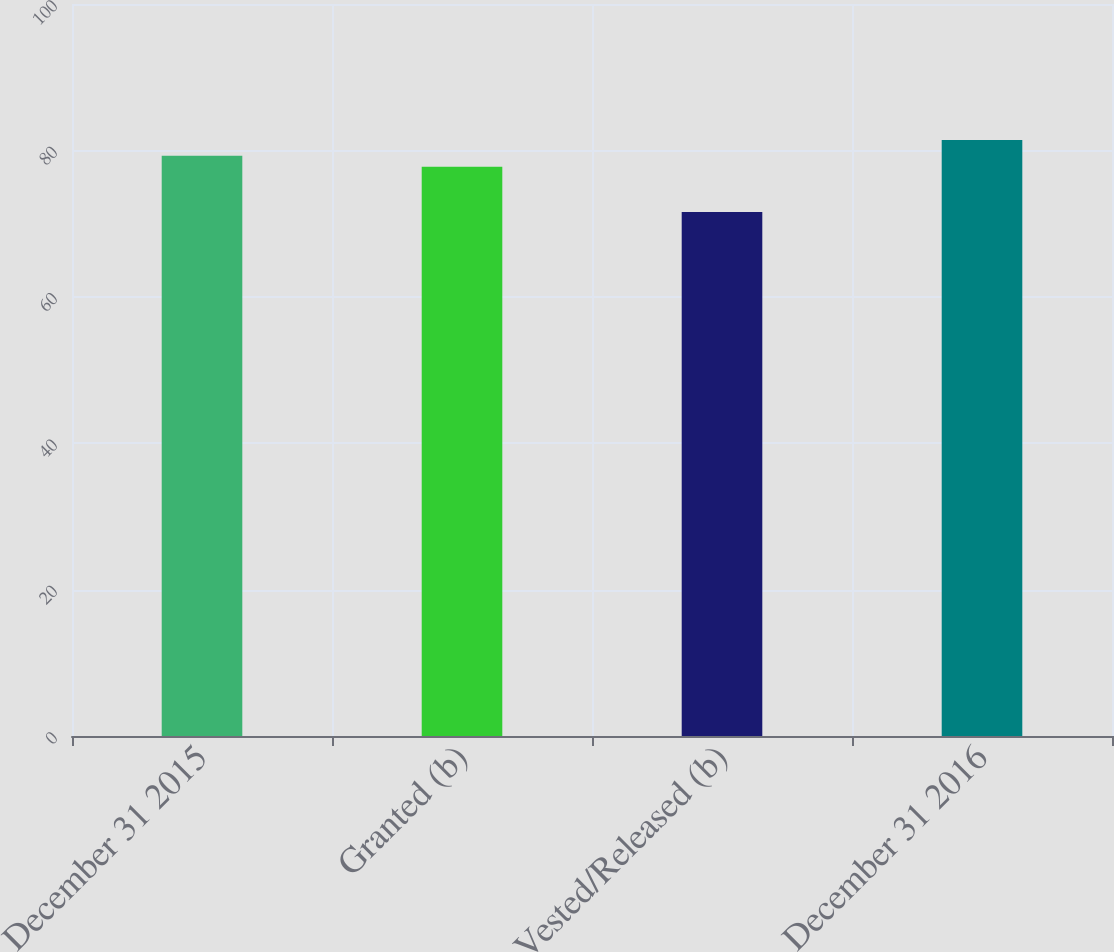Convert chart. <chart><loc_0><loc_0><loc_500><loc_500><bar_chart><fcel>December 31 2015<fcel>Granted (b)<fcel>Vested/Released (b)<fcel>December 31 2016<nl><fcel>79.27<fcel>77.77<fcel>71.59<fcel>81.42<nl></chart> 